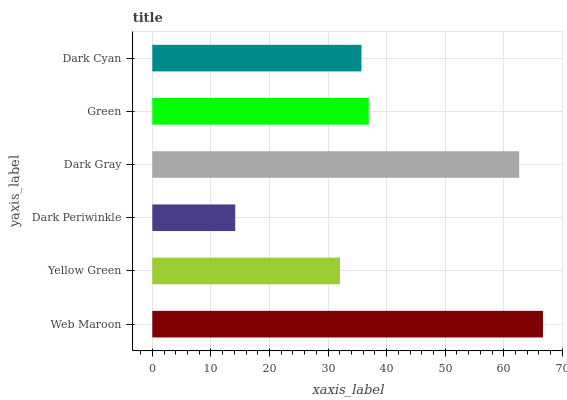Is Dark Periwinkle the minimum?
Answer yes or no. Yes. Is Web Maroon the maximum?
Answer yes or no. Yes. Is Yellow Green the minimum?
Answer yes or no. No. Is Yellow Green the maximum?
Answer yes or no. No. Is Web Maroon greater than Yellow Green?
Answer yes or no. Yes. Is Yellow Green less than Web Maroon?
Answer yes or no. Yes. Is Yellow Green greater than Web Maroon?
Answer yes or no. No. Is Web Maroon less than Yellow Green?
Answer yes or no. No. Is Green the high median?
Answer yes or no. Yes. Is Dark Cyan the low median?
Answer yes or no. Yes. Is Dark Gray the high median?
Answer yes or no. No. Is Green the low median?
Answer yes or no. No. 